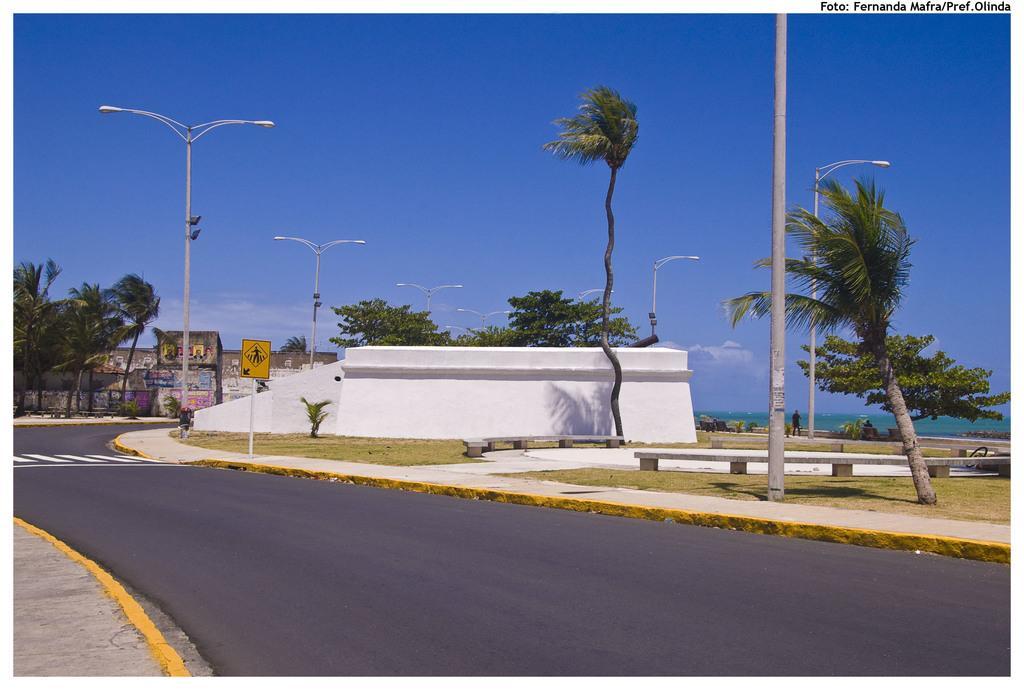Can you describe this image briefly? In this image we can see the road. And we can see the trees, grass. And we can see the street lights, wall. And we can see the clouds in the sky. And we can see the sign boards. 